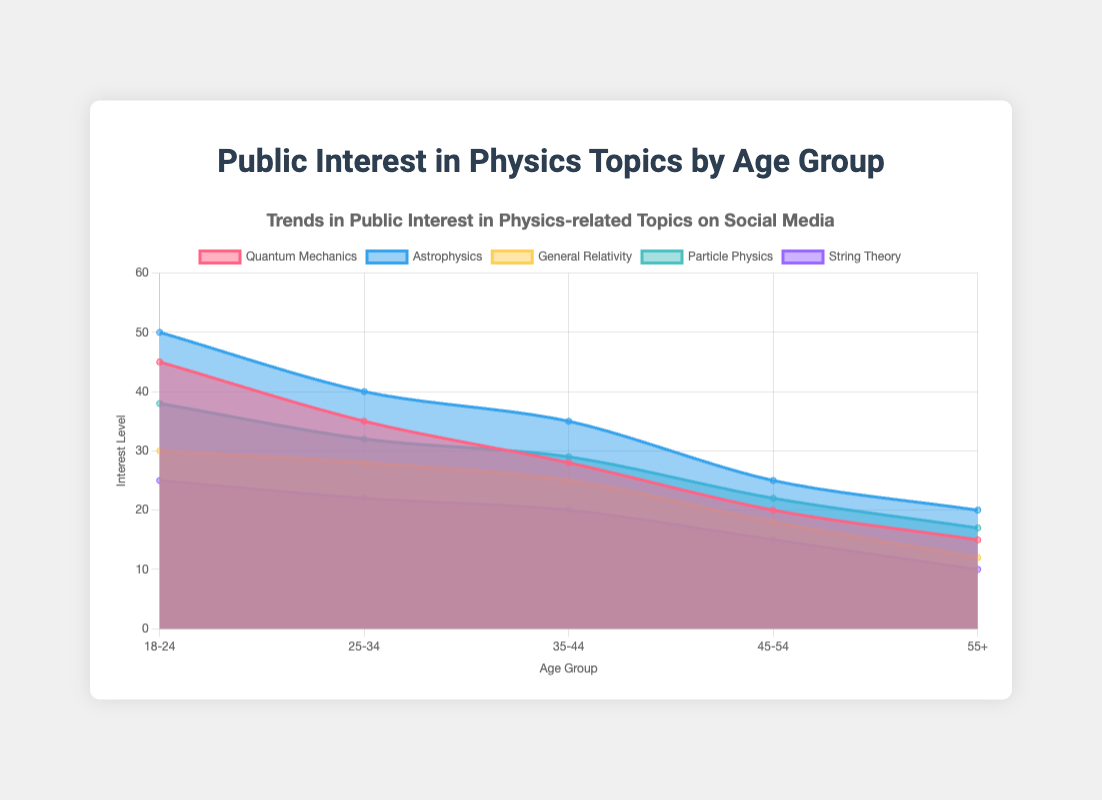What is the title of the figure? The title of the figure is displayed at the top and reads "Trends in Public Interest in Physics-related Topics on Social Media".
Answer: Trends in Public Interest in Physics-related Topics on Social Media What does the y-axis represent in the figure? The y-axis represents the "Interest Level", which could be measured by metrics such as mentions, likes, or engagement on social media.
Answer: Interest Level Which physics topic has the highest interest level in the 18-24 age group? By looking at the data points specifically for the 18-24 age group, the highest interest level is for "Astrophysics" with a value of 50.
Answer: Astrophysics How does the interest level in String Theory change across the age groups? The interest level in String Theory starts at 25 for the 18-24 age group and decreases gradually to 10 for the 55+ age group.
Answer: Decreases Between which two consecutive age groups is the interest in Quantum Mechanics declining the most? Observing the data points for Quantum Mechanics, there is a significant drop between the 18-24 age group (45) and the 25-34 age group (35), indicating a decline of 10 points.
Answer: 18-24 and 25-34 What is the average interest level in Astrophysics across all age groups? The interest levels in Astrophysics are 50, 40, 35, 25, and 20. Adding these values gives 50+40+35+25+20 = 170. Dividing by the 5 age groups, the average is 170 / 5 = 34.
Answer: 34 Which age group shows the least interest in Particle Physics? Looking for the lowest data point for Particle Physics, the 55+ age group has the least interest with a value of 17.
Answer: 55+ Is there any age group where General Relativity and Particle Physics have the same interest level? By comparing the values for General Relativity and Particle Physics across all age groups, none have matching values.
Answer: No Across all age groups, which physics topic shows the most consistent trend in interest level? Observing all datasets, String Theory shows a consistent decreasing trend without fluctuations: 25, 22, 20, 15, and 10.
Answer: String Theory 